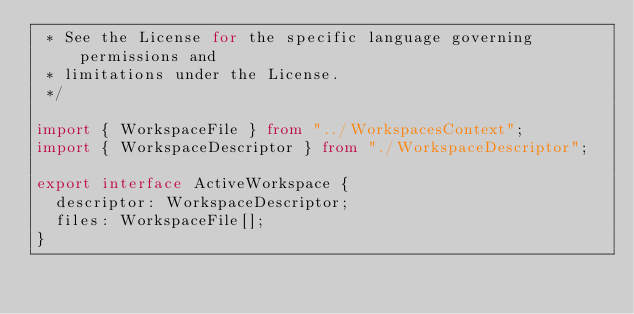Convert code to text. <code><loc_0><loc_0><loc_500><loc_500><_TypeScript_> * See the License for the specific language governing permissions and
 * limitations under the License.
 */

import { WorkspaceFile } from "../WorkspacesContext";
import { WorkspaceDescriptor } from "./WorkspaceDescriptor";

export interface ActiveWorkspace {
  descriptor: WorkspaceDescriptor;
  files: WorkspaceFile[];
}
</code> 